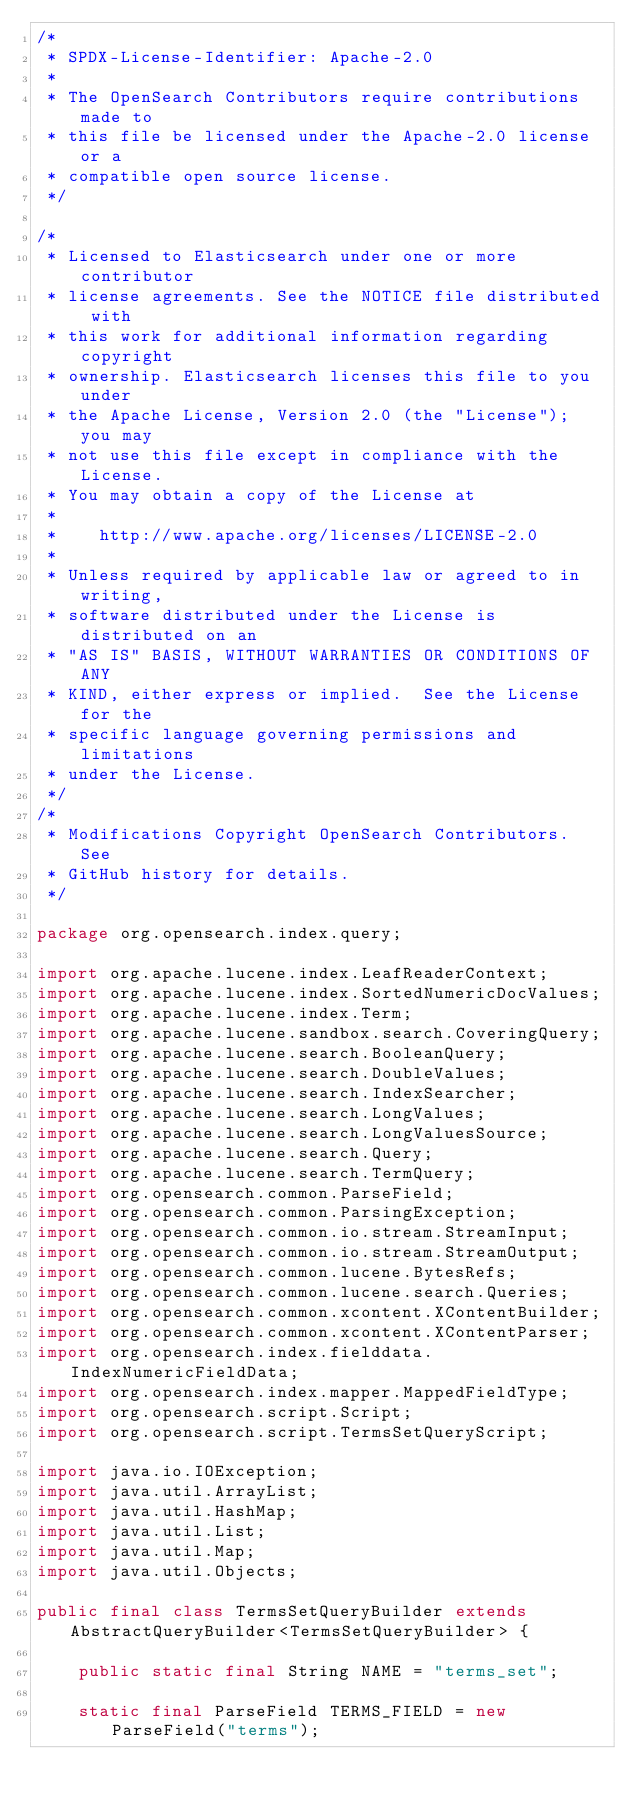<code> <loc_0><loc_0><loc_500><loc_500><_Java_>/*
 * SPDX-License-Identifier: Apache-2.0
 *
 * The OpenSearch Contributors require contributions made to
 * this file be licensed under the Apache-2.0 license or a
 * compatible open source license.
 */

/*
 * Licensed to Elasticsearch under one or more contributor
 * license agreements. See the NOTICE file distributed with
 * this work for additional information regarding copyright
 * ownership. Elasticsearch licenses this file to you under
 * the Apache License, Version 2.0 (the "License"); you may
 * not use this file except in compliance with the License.
 * You may obtain a copy of the License at
 *
 *    http://www.apache.org/licenses/LICENSE-2.0
 *
 * Unless required by applicable law or agreed to in writing,
 * software distributed under the License is distributed on an
 * "AS IS" BASIS, WITHOUT WARRANTIES OR CONDITIONS OF ANY
 * KIND, either express or implied.  See the License for the
 * specific language governing permissions and limitations
 * under the License.
 */
/*
 * Modifications Copyright OpenSearch Contributors. See
 * GitHub history for details.
 */

package org.opensearch.index.query;

import org.apache.lucene.index.LeafReaderContext;
import org.apache.lucene.index.SortedNumericDocValues;
import org.apache.lucene.index.Term;
import org.apache.lucene.sandbox.search.CoveringQuery;
import org.apache.lucene.search.BooleanQuery;
import org.apache.lucene.search.DoubleValues;
import org.apache.lucene.search.IndexSearcher;
import org.apache.lucene.search.LongValues;
import org.apache.lucene.search.LongValuesSource;
import org.apache.lucene.search.Query;
import org.apache.lucene.search.TermQuery;
import org.opensearch.common.ParseField;
import org.opensearch.common.ParsingException;
import org.opensearch.common.io.stream.StreamInput;
import org.opensearch.common.io.stream.StreamOutput;
import org.opensearch.common.lucene.BytesRefs;
import org.opensearch.common.lucene.search.Queries;
import org.opensearch.common.xcontent.XContentBuilder;
import org.opensearch.common.xcontent.XContentParser;
import org.opensearch.index.fielddata.IndexNumericFieldData;
import org.opensearch.index.mapper.MappedFieldType;
import org.opensearch.script.Script;
import org.opensearch.script.TermsSetQueryScript;

import java.io.IOException;
import java.util.ArrayList;
import java.util.HashMap;
import java.util.List;
import java.util.Map;
import java.util.Objects;

public final class TermsSetQueryBuilder extends AbstractQueryBuilder<TermsSetQueryBuilder> {

    public static final String NAME = "terms_set";

    static final ParseField TERMS_FIELD = new ParseField("terms");</code> 